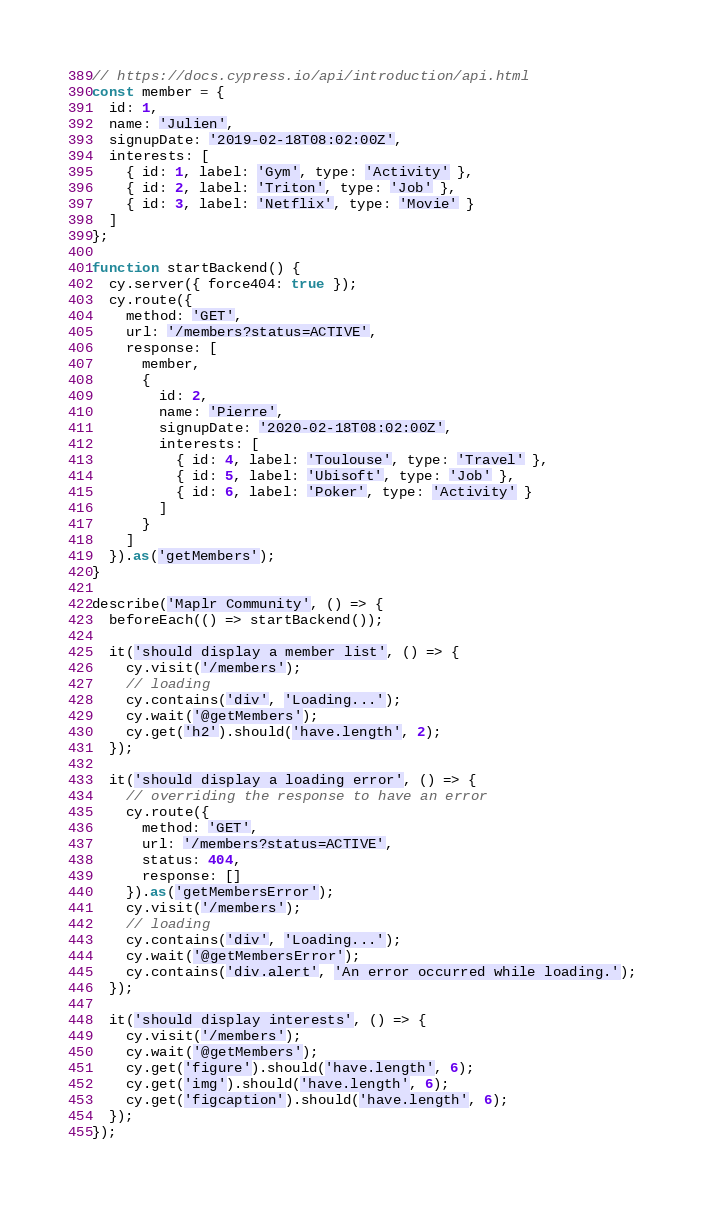<code> <loc_0><loc_0><loc_500><loc_500><_JavaScript_>// https://docs.cypress.io/api/introduction/api.html
const member = {
  id: 1,
  name: 'Julien',
  signupDate: '2019-02-18T08:02:00Z',
  interests: [
    { id: 1, label: 'Gym', type: 'Activity' },
    { id: 2, label: 'Triton', type: 'Job' },
    { id: 3, label: 'Netflix', type: 'Movie' }
  ]
};

function startBackend() {
  cy.server({ force404: true });
  cy.route({
    method: 'GET',
    url: '/members?status=ACTIVE',
    response: [
      member,
      {
        id: 2,
        name: 'Pierre',
        signupDate: '2020-02-18T08:02:00Z',
        interests: [
          { id: 4, label: 'Toulouse', type: 'Travel' },
          { id: 5, label: 'Ubisoft', type: 'Job' },
          { id: 6, label: 'Poker', type: 'Activity' }
        ]
      }
    ]
  }).as('getMembers');
}

describe('Maplr Community', () => {
  beforeEach(() => startBackend());

  it('should display a member list', () => {
    cy.visit('/members');
    // loading
    cy.contains('div', 'Loading...');
    cy.wait('@getMembers');
    cy.get('h2').should('have.length', 2);
  });

  it('should display a loading error', () => {
    // overriding the response to have an error
    cy.route({
      method: 'GET',
      url: '/members?status=ACTIVE',
      status: 404,
      response: []
    }).as('getMembersError');
    cy.visit('/members');
    // loading
    cy.contains('div', 'Loading...');
    cy.wait('@getMembersError');
    cy.contains('div.alert', 'An error occurred while loading.');
  });

  it('should display interests', () => {
    cy.visit('/members');
    cy.wait('@getMembers');
    cy.get('figure').should('have.length', 6);
    cy.get('img').should('have.length', 6);
    cy.get('figcaption').should('have.length', 6);
  });
});
</code> 